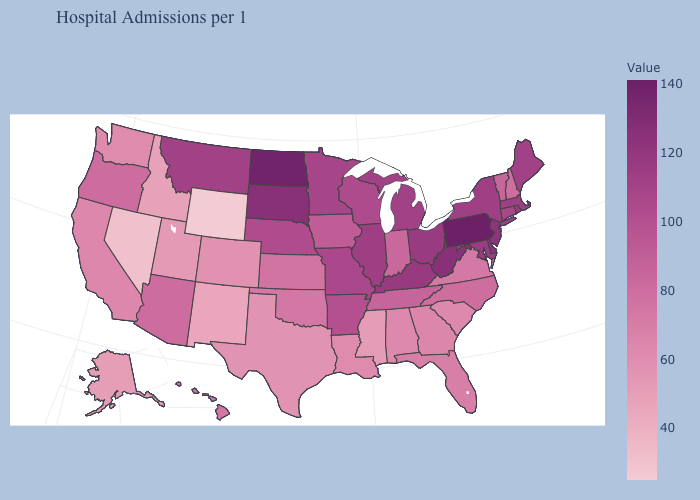Is the legend a continuous bar?
Concise answer only. Yes. Which states hav the highest value in the Northeast?
Keep it brief. Pennsylvania. Among the states that border Florida , which have the highest value?
Write a very short answer. Georgia. Does West Virginia have a lower value than Pennsylvania?
Short answer required. Yes. Does South Carolina have the lowest value in the South?
Quick response, please. No. 